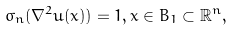<formula> <loc_0><loc_0><loc_500><loc_500>\sigma _ { n } ( \nabla ^ { 2 } u ( x ) ) = 1 , x \in B _ { 1 } \subset \mathbb { R } ^ { n } ,</formula> 